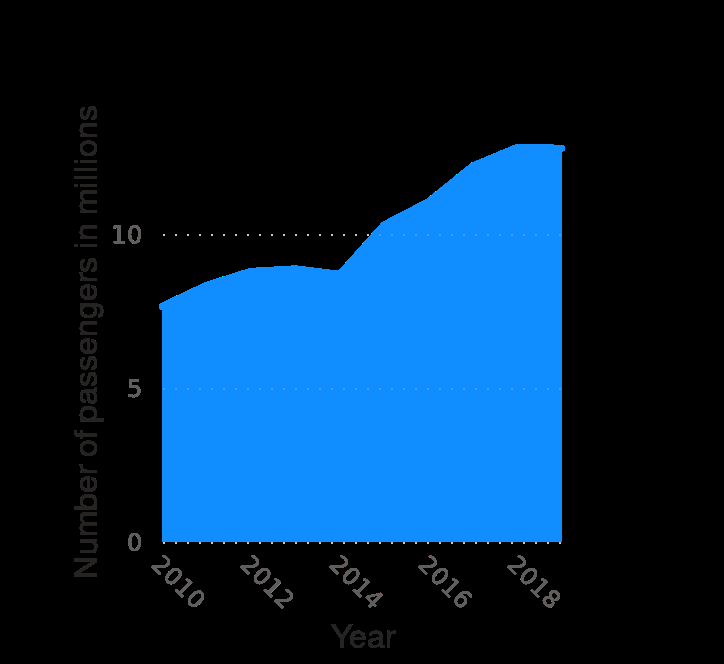<image>
What is the title of the diagram?  The diagram is titled "Annual number of passengers traveling through Bergamo Orio al Serio Airport in Italy from 2010 to 2019 (in millions)." please summary the statistics and relations of the chart There is an overall trend of passengers numbers increasing over time with the only exception being in 2014 where there was a slight decrease/plateau but the number of passengers then exponentially increases before plateauing again in 2018 at approx 15 million passengers. How did the number of passengers change between 2010 and 2012? The number of passengers increased from around 7.5 million in 2010 to over 8 million in 2012. 